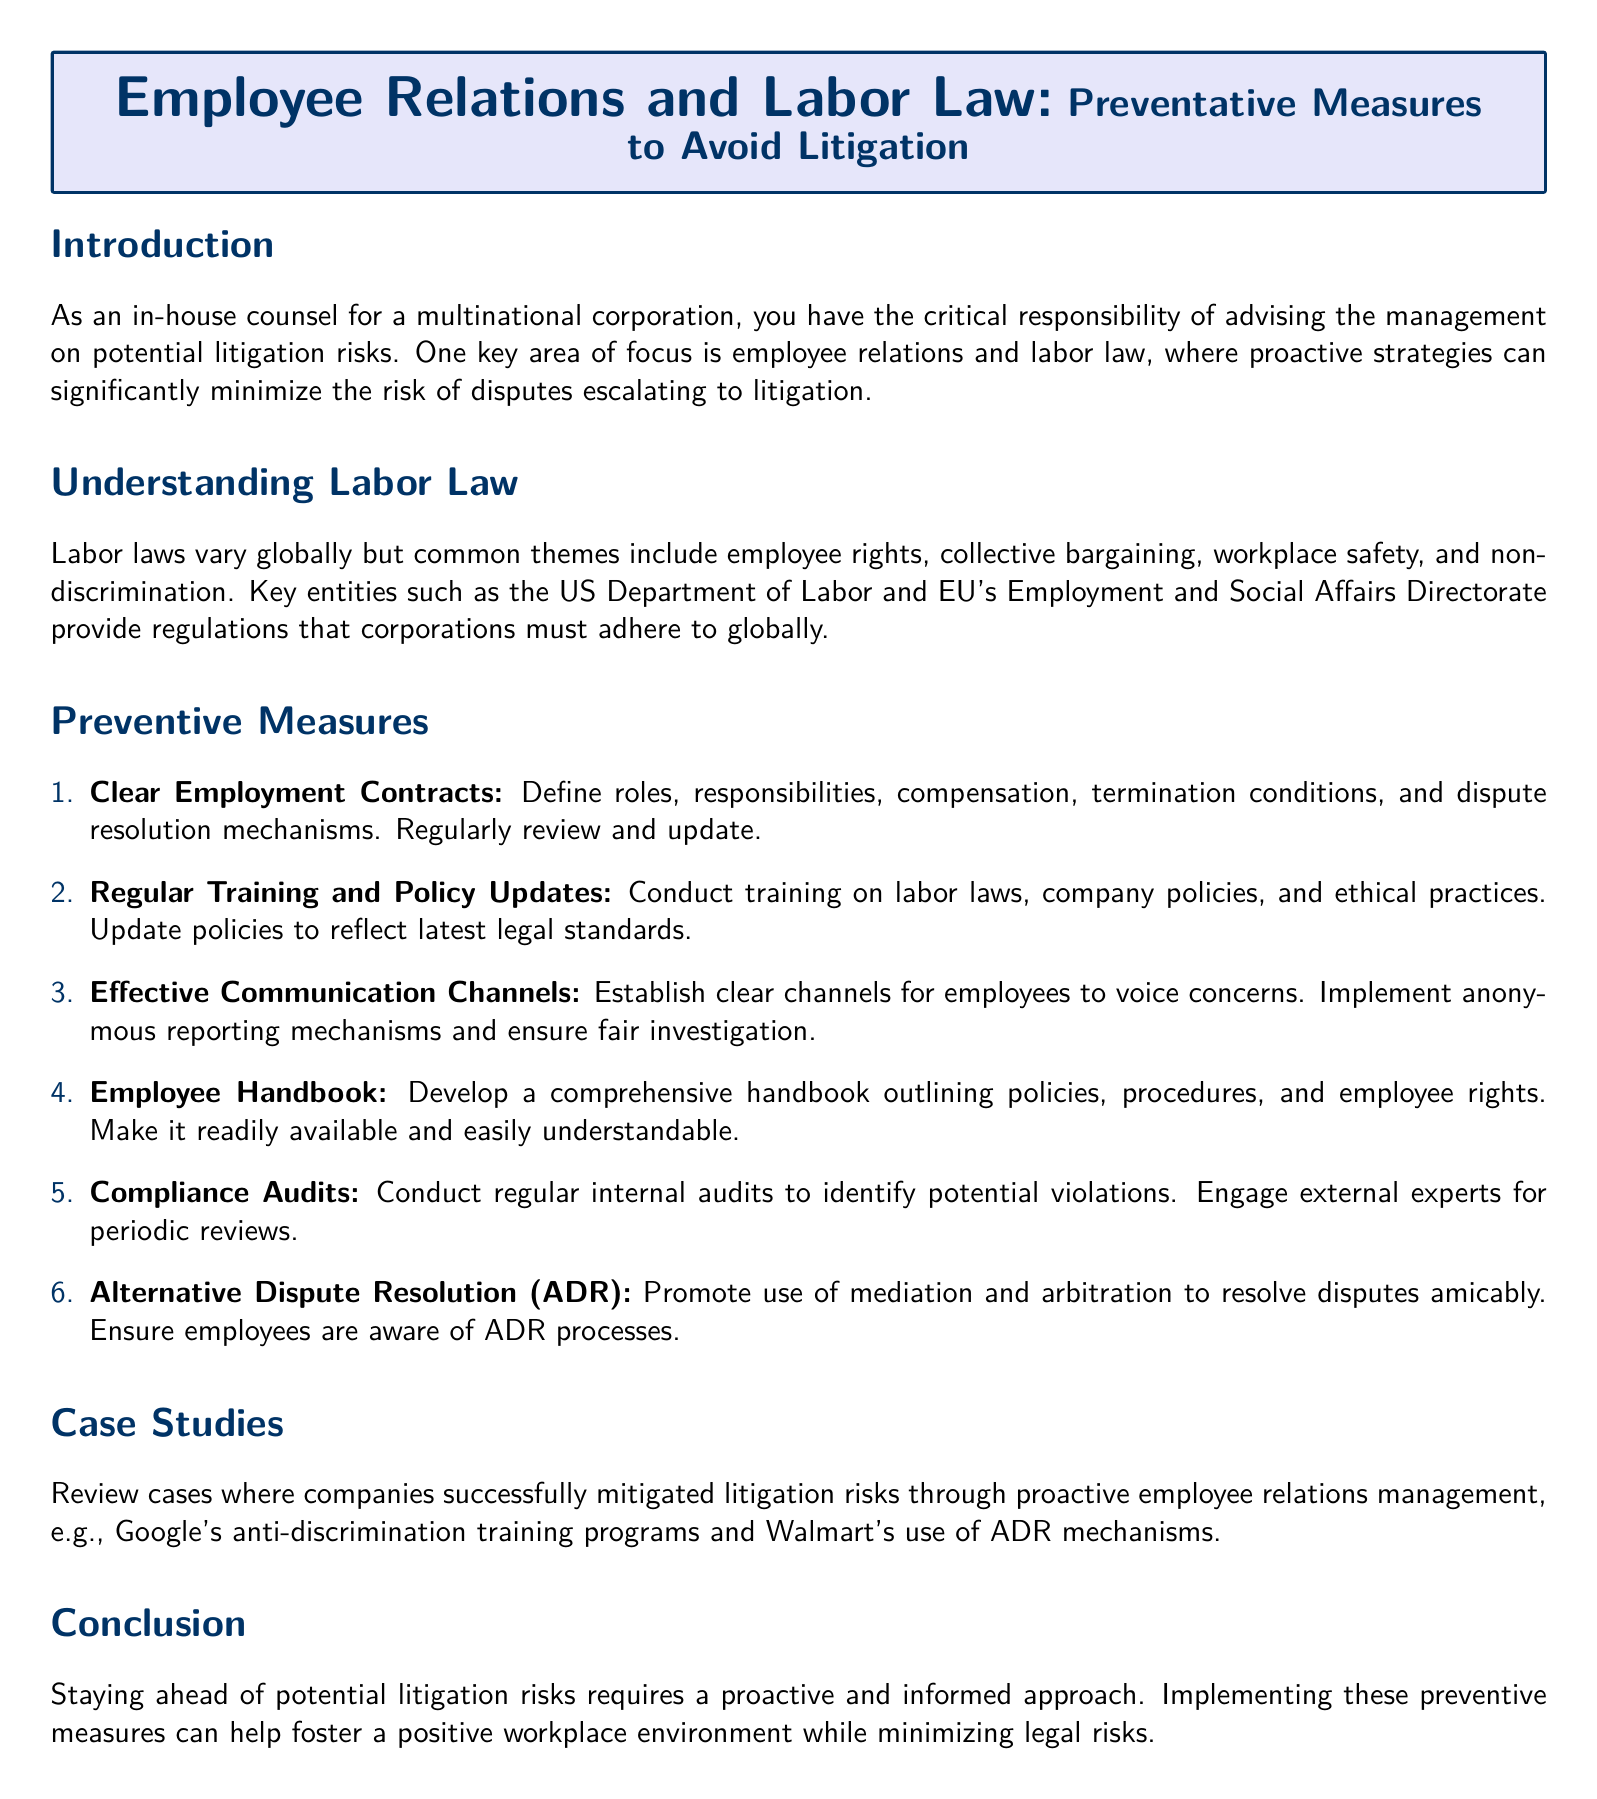What is the main title of the document? The main title is presented in the tcolorbox at the beginning of the document.
Answer: Employee Relations and Labor Law: Preventative Measures to Avoid Litigation How many preventive measures are listed? The document lists preventive measures in an enumerated format.
Answer: Six Which key entity is mentioned regarding labor laws in the US? The document mentions key entities that provide regulations, specifically in relation to labor laws.
Answer: US Department of Labor What is one of the roles defined in clear employment contracts? Clear employment contracts are mentioned to include several defined roles and aspects.
Answer: Responsibilities What does ADR stand for in the context of dispute resolution? ADR is an abbreviation used within the section discussing dispute resolution mechanisms.
Answer: Alternative Dispute Resolution What notable company is mentioned as having proactive employee relations management? The document cites specific case studies as examples of successful practices.
Answer: Google What is the purpose of compliance audits? The document describes regular compliance audits in terms of identifying potential legal issues.
Answer: Identify potential violations What should employees have access to according to the employee handbook? The employee handbook is mentioned as providing critical information to employees.
Answer: Policies, procedures, and employee rights What is recommended to update regularly in preventive measures? The preventive measures emphasize the importance of maintaining certain items to reflect changes in law.
Answer: Policies 